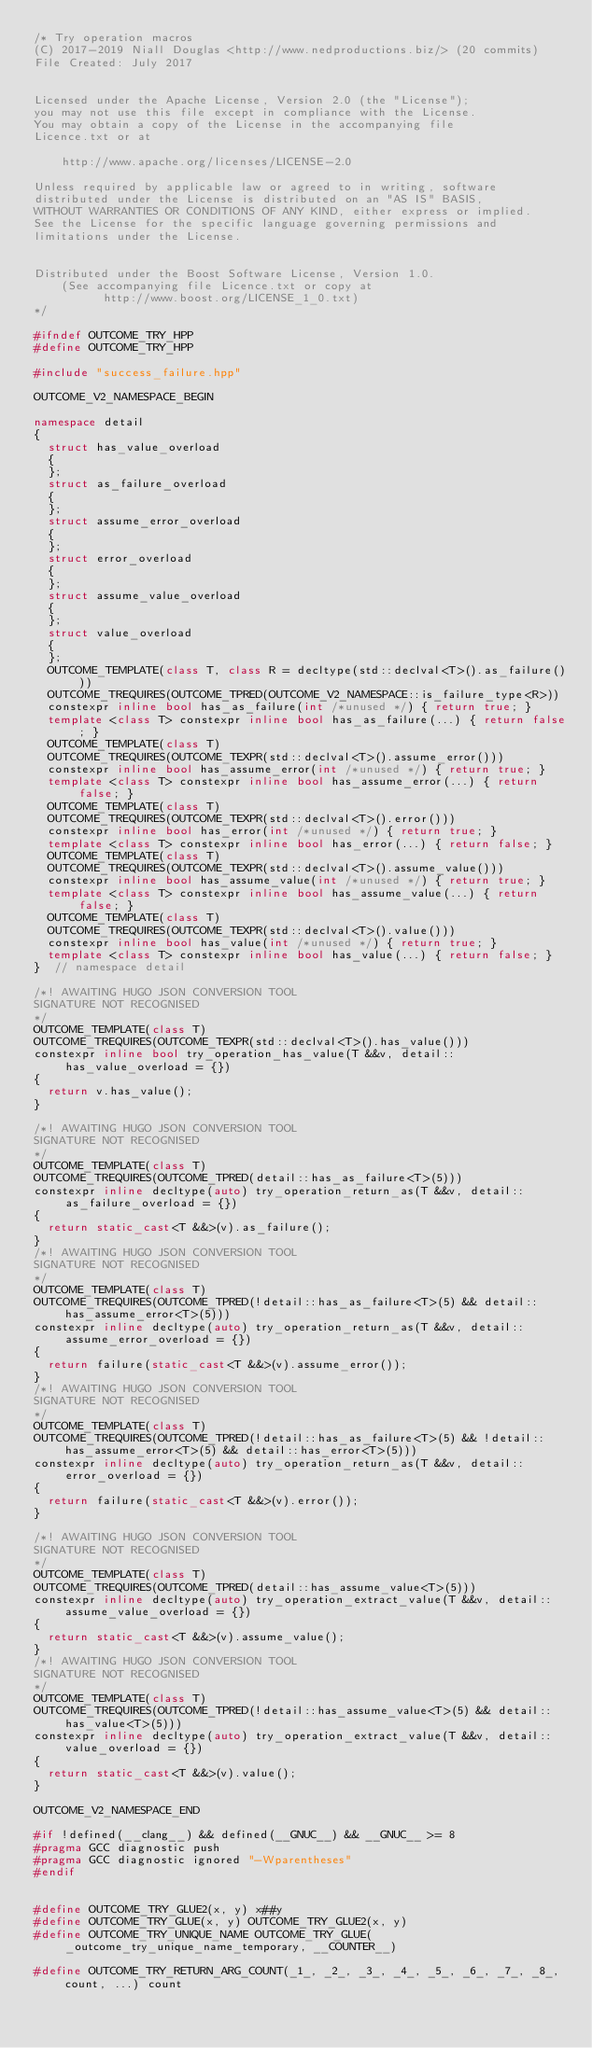<code> <loc_0><loc_0><loc_500><loc_500><_C++_>/* Try operation macros
(C) 2017-2019 Niall Douglas <http://www.nedproductions.biz/> (20 commits)
File Created: July 2017


Licensed under the Apache License, Version 2.0 (the "License");
you may not use this file except in compliance with the License.
You may obtain a copy of the License in the accompanying file
Licence.txt or at

    http://www.apache.org/licenses/LICENSE-2.0

Unless required by applicable law or agreed to in writing, software
distributed under the License is distributed on an "AS IS" BASIS,
WITHOUT WARRANTIES OR CONDITIONS OF ANY KIND, either express or implied.
See the License for the specific language governing permissions and
limitations under the License.


Distributed under the Boost Software License, Version 1.0.
    (See accompanying file Licence.txt or copy at
          http://www.boost.org/LICENSE_1_0.txt)
*/

#ifndef OUTCOME_TRY_HPP
#define OUTCOME_TRY_HPP

#include "success_failure.hpp"

OUTCOME_V2_NAMESPACE_BEGIN

namespace detail
{
  struct has_value_overload
  {
  };
  struct as_failure_overload
  {
  };
  struct assume_error_overload
  {
  };
  struct error_overload
  {
  };
  struct assume_value_overload
  {
  };
  struct value_overload
  {
  };
  OUTCOME_TEMPLATE(class T, class R = decltype(std::declval<T>().as_failure()))
  OUTCOME_TREQUIRES(OUTCOME_TPRED(OUTCOME_V2_NAMESPACE::is_failure_type<R>))
  constexpr inline bool has_as_failure(int /*unused */) { return true; }
  template <class T> constexpr inline bool has_as_failure(...) { return false; }
  OUTCOME_TEMPLATE(class T)
  OUTCOME_TREQUIRES(OUTCOME_TEXPR(std::declval<T>().assume_error()))
  constexpr inline bool has_assume_error(int /*unused */) { return true; }
  template <class T> constexpr inline bool has_assume_error(...) { return false; }
  OUTCOME_TEMPLATE(class T)
  OUTCOME_TREQUIRES(OUTCOME_TEXPR(std::declval<T>().error()))
  constexpr inline bool has_error(int /*unused */) { return true; }
  template <class T> constexpr inline bool has_error(...) { return false; }
  OUTCOME_TEMPLATE(class T)
  OUTCOME_TREQUIRES(OUTCOME_TEXPR(std::declval<T>().assume_value()))
  constexpr inline bool has_assume_value(int /*unused */) { return true; }
  template <class T> constexpr inline bool has_assume_value(...) { return false; }
  OUTCOME_TEMPLATE(class T)
  OUTCOME_TREQUIRES(OUTCOME_TEXPR(std::declval<T>().value()))
  constexpr inline bool has_value(int /*unused */) { return true; }
  template <class T> constexpr inline bool has_value(...) { return false; }
}  // namespace detail

/*! AWAITING HUGO JSON CONVERSION TOOL
SIGNATURE NOT RECOGNISED
*/
OUTCOME_TEMPLATE(class T)
OUTCOME_TREQUIRES(OUTCOME_TEXPR(std::declval<T>().has_value()))
constexpr inline bool try_operation_has_value(T &&v, detail::has_value_overload = {})
{
  return v.has_value();
}

/*! AWAITING HUGO JSON CONVERSION TOOL
SIGNATURE NOT RECOGNISED
*/
OUTCOME_TEMPLATE(class T)
OUTCOME_TREQUIRES(OUTCOME_TPRED(detail::has_as_failure<T>(5)))
constexpr inline decltype(auto) try_operation_return_as(T &&v, detail::as_failure_overload = {})
{
  return static_cast<T &&>(v).as_failure();
}
/*! AWAITING HUGO JSON CONVERSION TOOL
SIGNATURE NOT RECOGNISED
*/
OUTCOME_TEMPLATE(class T)
OUTCOME_TREQUIRES(OUTCOME_TPRED(!detail::has_as_failure<T>(5) && detail::has_assume_error<T>(5)))
constexpr inline decltype(auto) try_operation_return_as(T &&v, detail::assume_error_overload = {})
{
  return failure(static_cast<T &&>(v).assume_error());
}
/*! AWAITING HUGO JSON CONVERSION TOOL
SIGNATURE NOT RECOGNISED
*/
OUTCOME_TEMPLATE(class T)
OUTCOME_TREQUIRES(OUTCOME_TPRED(!detail::has_as_failure<T>(5) && !detail::has_assume_error<T>(5) && detail::has_error<T>(5)))
constexpr inline decltype(auto) try_operation_return_as(T &&v, detail::error_overload = {})
{
  return failure(static_cast<T &&>(v).error());
}

/*! AWAITING HUGO JSON CONVERSION TOOL
SIGNATURE NOT RECOGNISED
*/
OUTCOME_TEMPLATE(class T)
OUTCOME_TREQUIRES(OUTCOME_TPRED(detail::has_assume_value<T>(5)))
constexpr inline decltype(auto) try_operation_extract_value(T &&v, detail::assume_value_overload = {})
{
  return static_cast<T &&>(v).assume_value();
}
/*! AWAITING HUGO JSON CONVERSION TOOL
SIGNATURE NOT RECOGNISED
*/
OUTCOME_TEMPLATE(class T)
OUTCOME_TREQUIRES(OUTCOME_TPRED(!detail::has_assume_value<T>(5) && detail::has_value<T>(5)))
constexpr inline decltype(auto) try_operation_extract_value(T &&v, detail::value_overload = {})
{
  return static_cast<T &&>(v).value();
}

OUTCOME_V2_NAMESPACE_END

#if !defined(__clang__) && defined(__GNUC__) && __GNUC__ >= 8
#pragma GCC diagnostic push
#pragma GCC diagnostic ignored "-Wparentheses"
#endif


#define OUTCOME_TRY_GLUE2(x, y) x##y
#define OUTCOME_TRY_GLUE(x, y) OUTCOME_TRY_GLUE2(x, y)
#define OUTCOME_TRY_UNIQUE_NAME OUTCOME_TRY_GLUE(_outcome_try_unique_name_temporary, __COUNTER__)

#define OUTCOME_TRY_RETURN_ARG_COUNT(_1_, _2_, _3_, _4_, _5_, _6_, _7_, _8_, count, ...) count</code> 